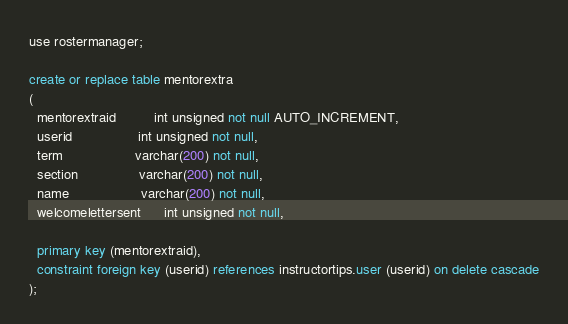Convert code to text. <code><loc_0><loc_0><loc_500><loc_500><_SQL_>use rostermanager;

create or replace table mentorextra
(
  mentorextraid          int unsigned not null AUTO_INCREMENT,
  userid                 int unsigned not null,
  term                   varchar(200) not null,
  section                varchar(200) not null,
  name                   varchar(200) not null,
  welcomelettersent      int unsigned not null,
  
  primary key (mentorextraid),
  constraint foreign key (userid) references instructortips.user (userid) on delete cascade
);</code> 